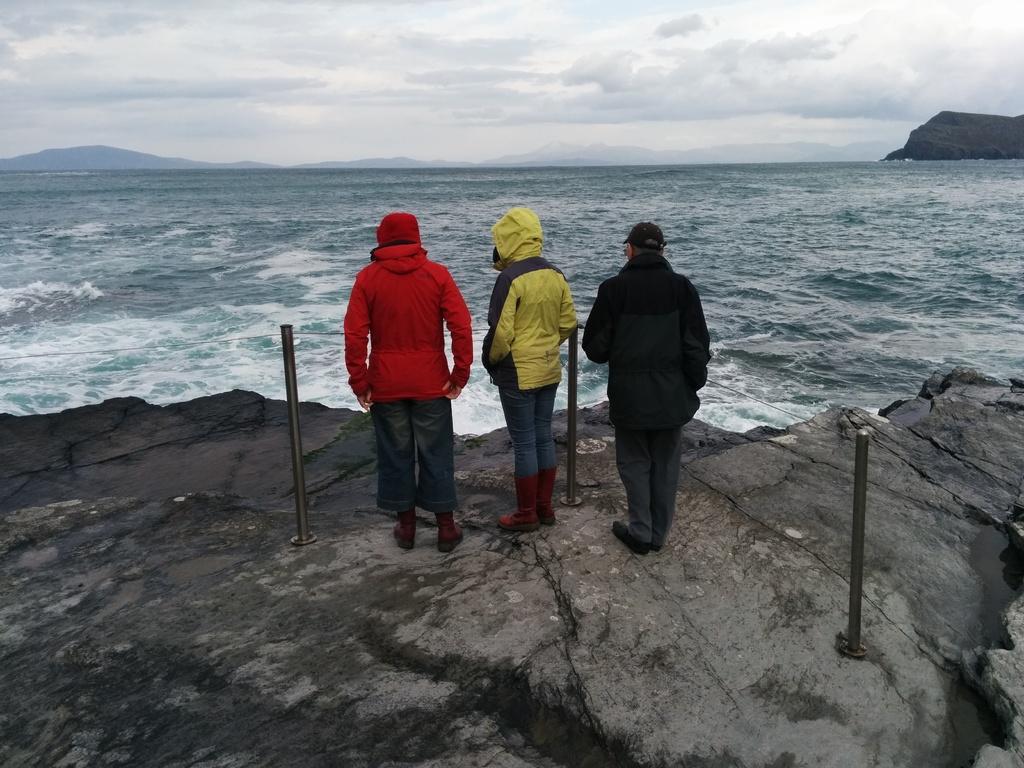Describe this image in one or two sentences. As we can see in the image there are three people standing in the front. There is water, sky and clouds. 